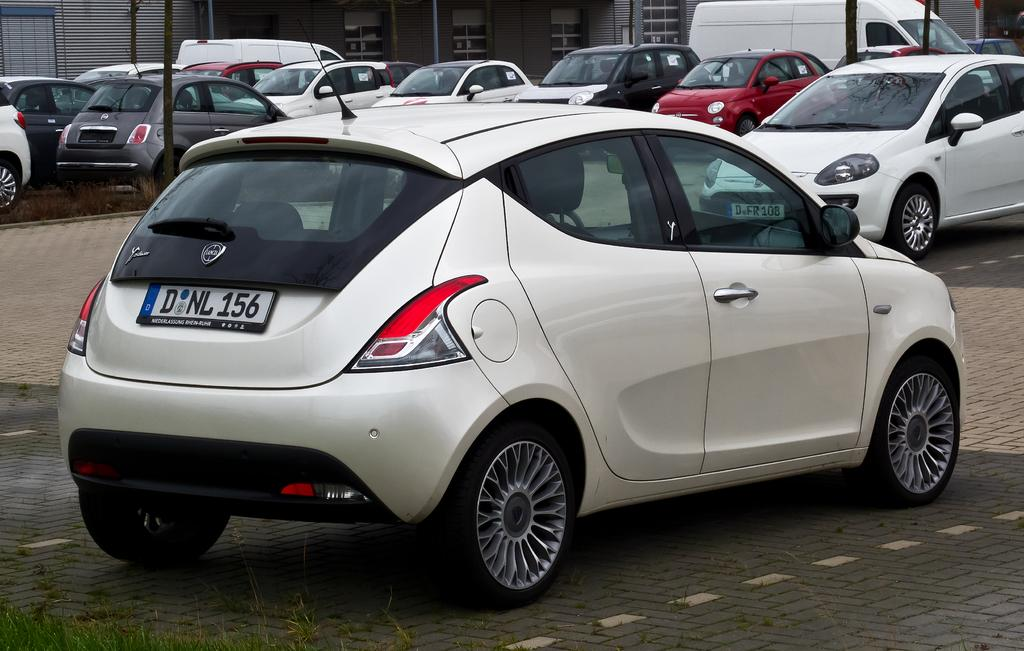What type of vehicles can be seen in the image? There are cars in the image. What can be found on the left side of the image? There is grass and a pole on the left side of the image. What is visible in the background of the image? There is a building and two vans in the background of the image. What type of brass instrument is being played by the person standing next to the pole? There is no brass instrument or person visible in the image; it only features cars, grass, a pole, a building, and two vans. 